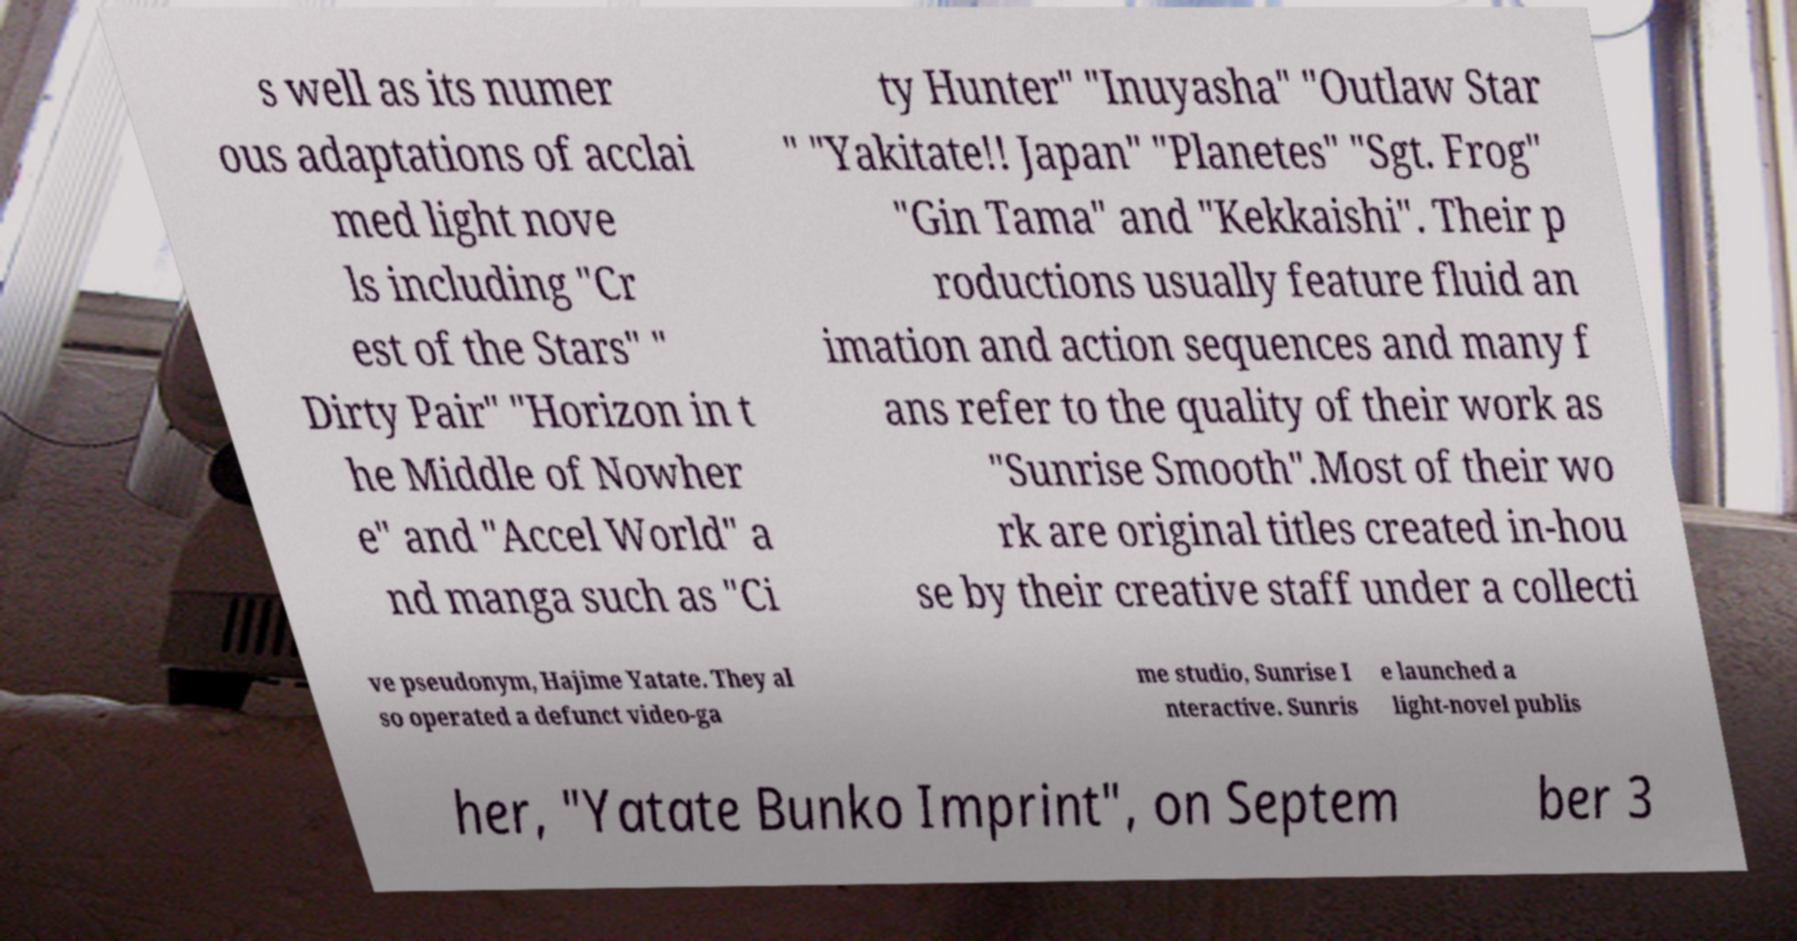There's text embedded in this image that I need extracted. Can you transcribe it verbatim? s well as its numer ous adaptations of acclai med light nove ls including "Cr est of the Stars" " Dirty Pair" "Horizon in t he Middle of Nowher e" and "Accel World" a nd manga such as "Ci ty Hunter" "Inuyasha" "Outlaw Star " "Yakitate!! Japan" "Planetes" "Sgt. Frog" "Gin Tama" and "Kekkaishi". Their p roductions usually feature fluid an imation and action sequences and many f ans refer to the quality of their work as "Sunrise Smooth".Most of their wo rk are original titles created in-hou se by their creative staff under a collecti ve pseudonym, Hajime Yatate. They al so operated a defunct video-ga me studio, Sunrise I nteractive. Sunris e launched a light-novel publis her, "Yatate Bunko Imprint", on Septem ber 3 